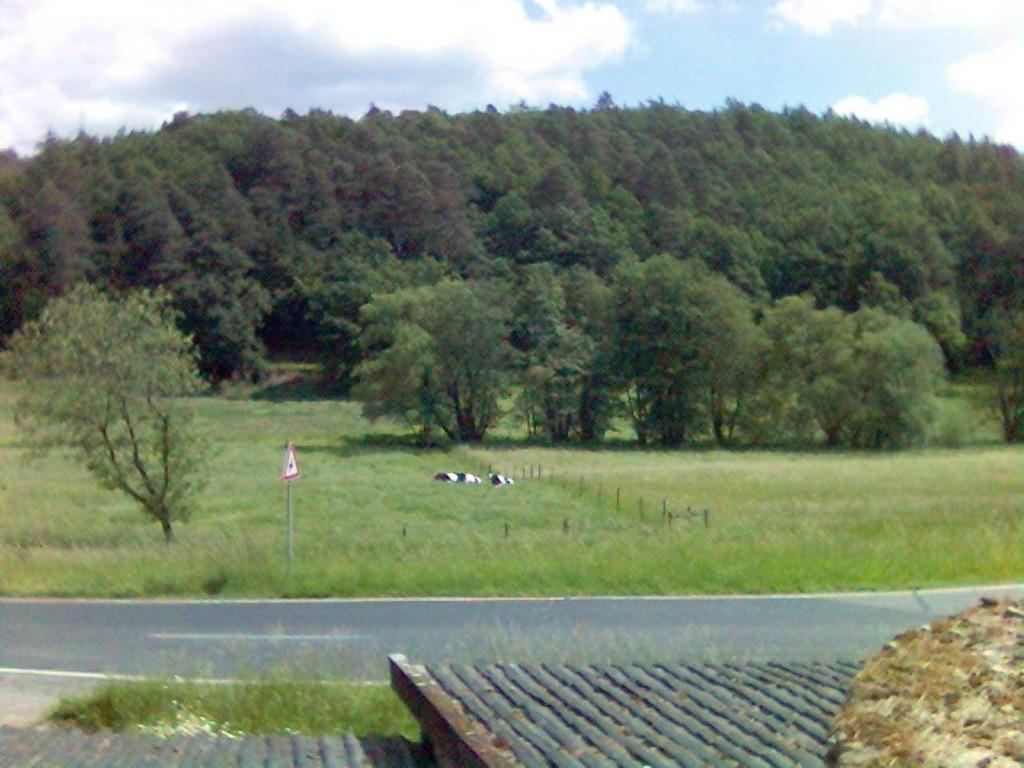What type of vegetation can be seen in the image? There are trees in the image. What is covering the ground in the image? The ground is covered with grass. What structures are present in the image? There are poles and a signboard in the image. What type of pathway is visible in the image? There is a road in the image. What is located at the bottom of the image? There is an object on the surface at the bottom of the image. What part of the natural environment is visible in the image? The sky is visible in the image, and clouds are present in the sky. What type of drug can be seen on the seashore in the image? There is no seashore or drug present in the image. 